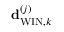<formula> <loc_0><loc_0><loc_500><loc_500>{ d } _ { W I N , k } ^ { \left ( j \right ) }</formula> 